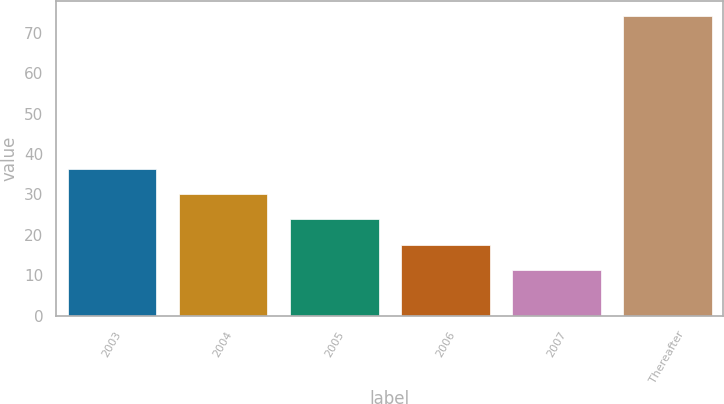<chart> <loc_0><loc_0><loc_500><loc_500><bar_chart><fcel>2003<fcel>2004<fcel>2005<fcel>2006<fcel>2007<fcel>Thereafter<nl><fcel>36.38<fcel>30.11<fcel>23.84<fcel>17.57<fcel>11.3<fcel>74<nl></chart> 